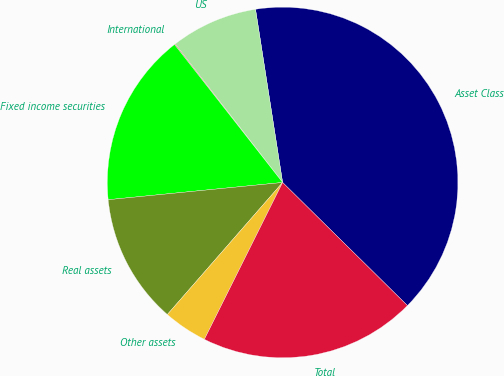Convert chart. <chart><loc_0><loc_0><loc_500><loc_500><pie_chart><fcel>Asset Class<fcel>US<fcel>International<fcel>Fixed income securities<fcel>Real assets<fcel>Other assets<fcel>Total<nl><fcel>39.86%<fcel>8.03%<fcel>0.08%<fcel>15.99%<fcel>12.01%<fcel>4.06%<fcel>19.97%<nl></chart> 